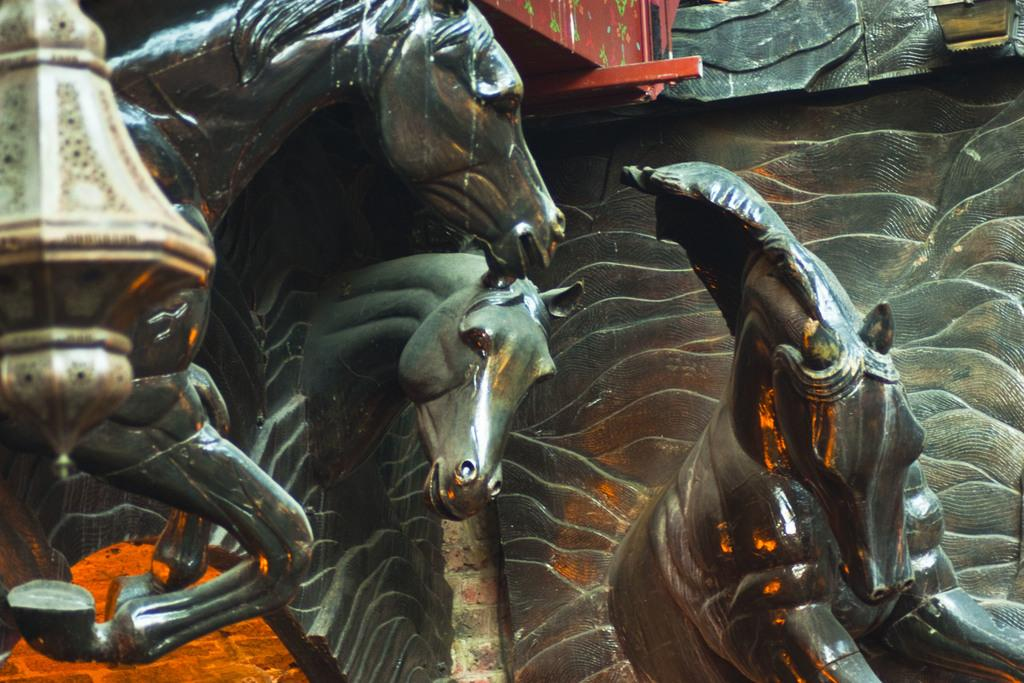What type of statues can be seen in the image? There are statues of horses in the image. What else can be seen in the image besides the statues of horses? There are other objects beside the statues of horses. What type of trade is being conducted with the clams in the image? There are no clams present in the image, so it is not possible to determine if any trade is being conducted. 